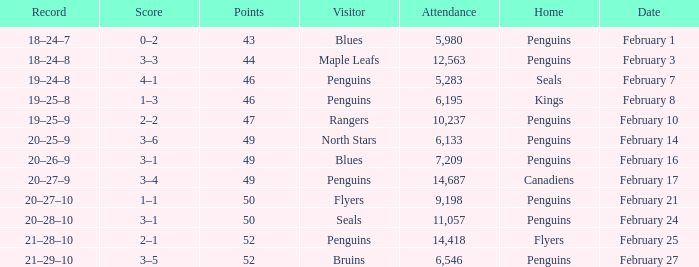Record of 21–29–10 had what total number of points? 1.0. 